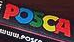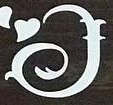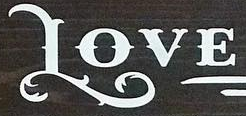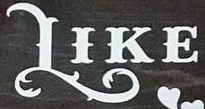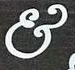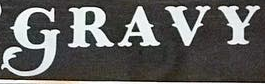Identify the words shown in these images in order, separated by a semicolon. POSCA; I; LOVE; LIKE; &; GRAVY 